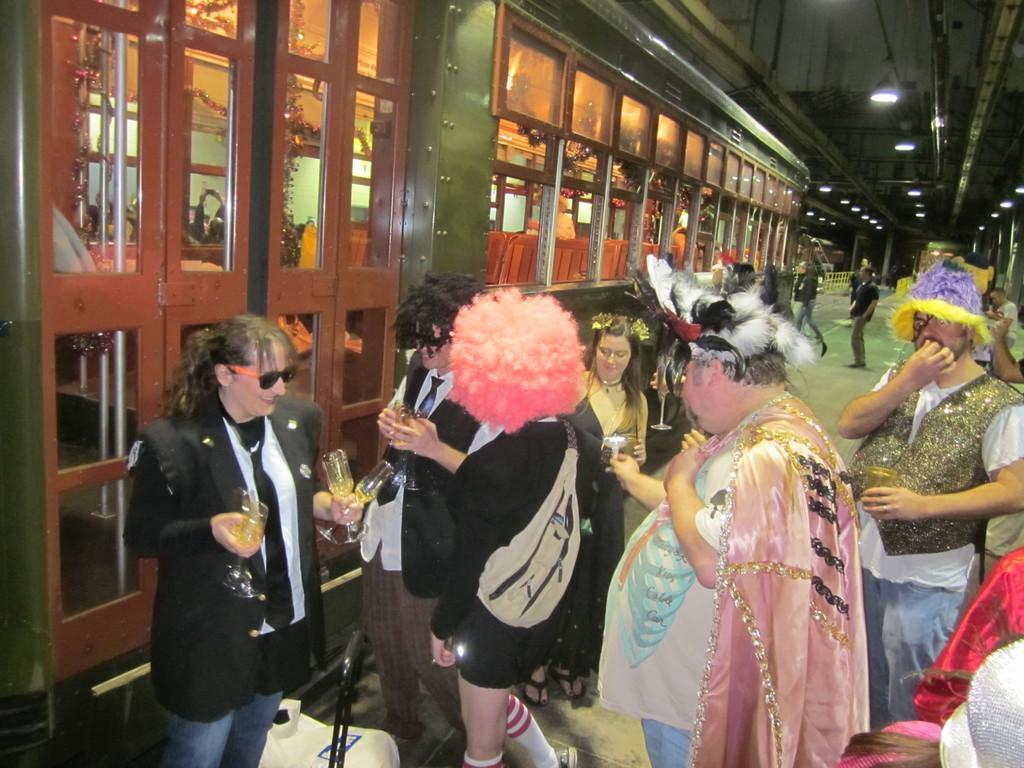Please provide a concise description of this image. In this image we can see few people wearing costumes. Some are holding glasses. Also there are glass doors and windows. On the ceiling there are lights. 